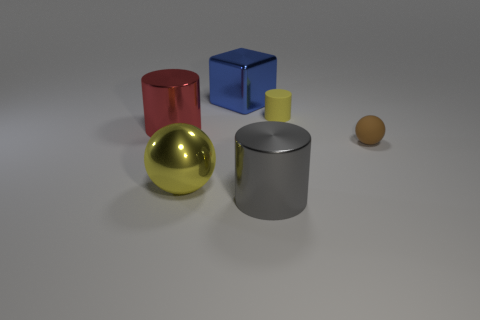Add 2 big gray metallic things. How many objects exist? 8 Subtract all spheres. How many objects are left? 4 Add 6 tiny spheres. How many tiny spheres exist? 7 Subtract 1 red cylinders. How many objects are left? 5 Subtract all purple rubber objects. Subtract all big yellow metallic objects. How many objects are left? 5 Add 4 big shiny objects. How many big shiny objects are left? 8 